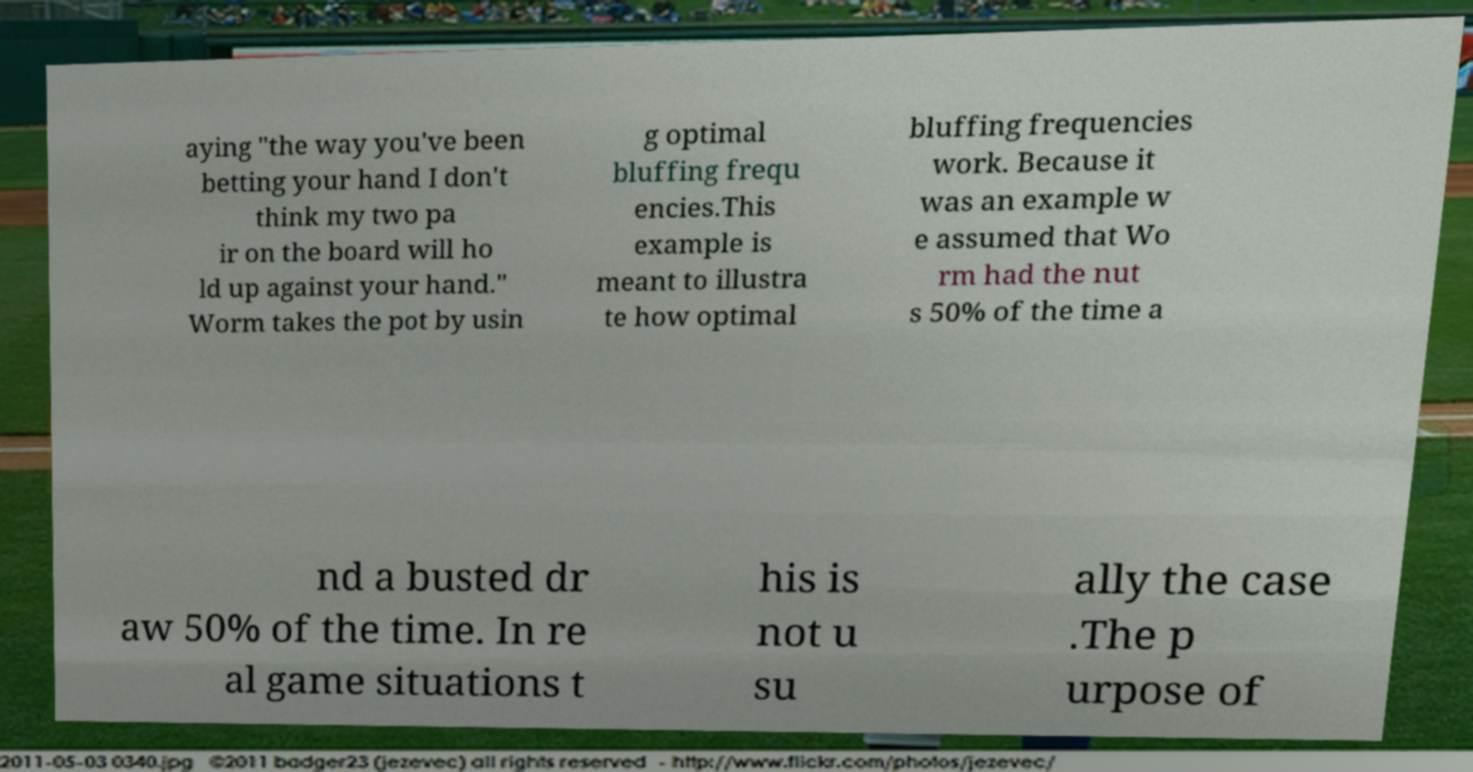Could you extract and type out the text from this image? aying "the way you've been betting your hand I don't think my two pa ir on the board will ho ld up against your hand." Worm takes the pot by usin g optimal bluffing frequ encies.This example is meant to illustra te how optimal bluffing frequencies work. Because it was an example w e assumed that Wo rm had the nut s 50% of the time a nd a busted dr aw 50% of the time. In re al game situations t his is not u su ally the case .The p urpose of 